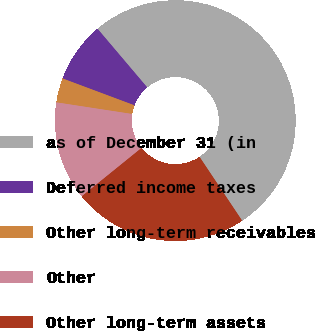Convert chart to OTSL. <chart><loc_0><loc_0><loc_500><loc_500><pie_chart><fcel>as of December 31 (in<fcel>Deferred income taxes<fcel>Other long-term receivables<fcel>Other<fcel>Other long-term assets<nl><fcel>51.82%<fcel>8.12%<fcel>3.27%<fcel>13.25%<fcel>23.54%<nl></chart> 